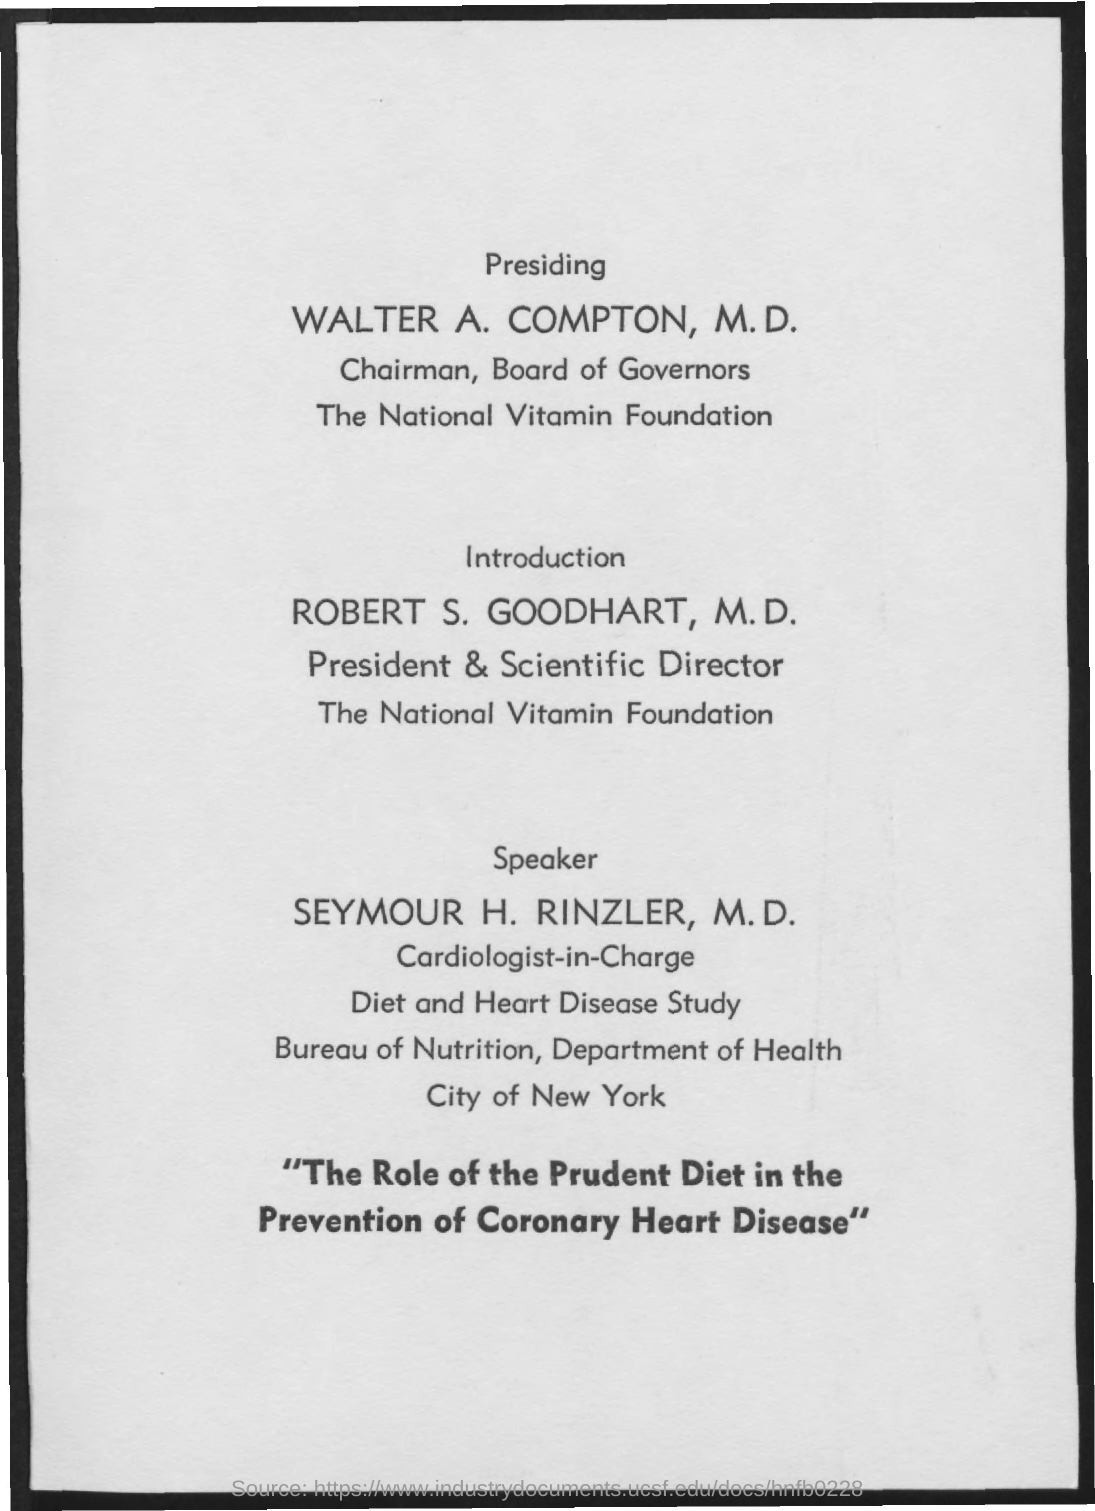Specify some key components in this picture. Robert S. Goodhart, M.D., is the President and Scientific Director of the National Vitamin Foundation. 